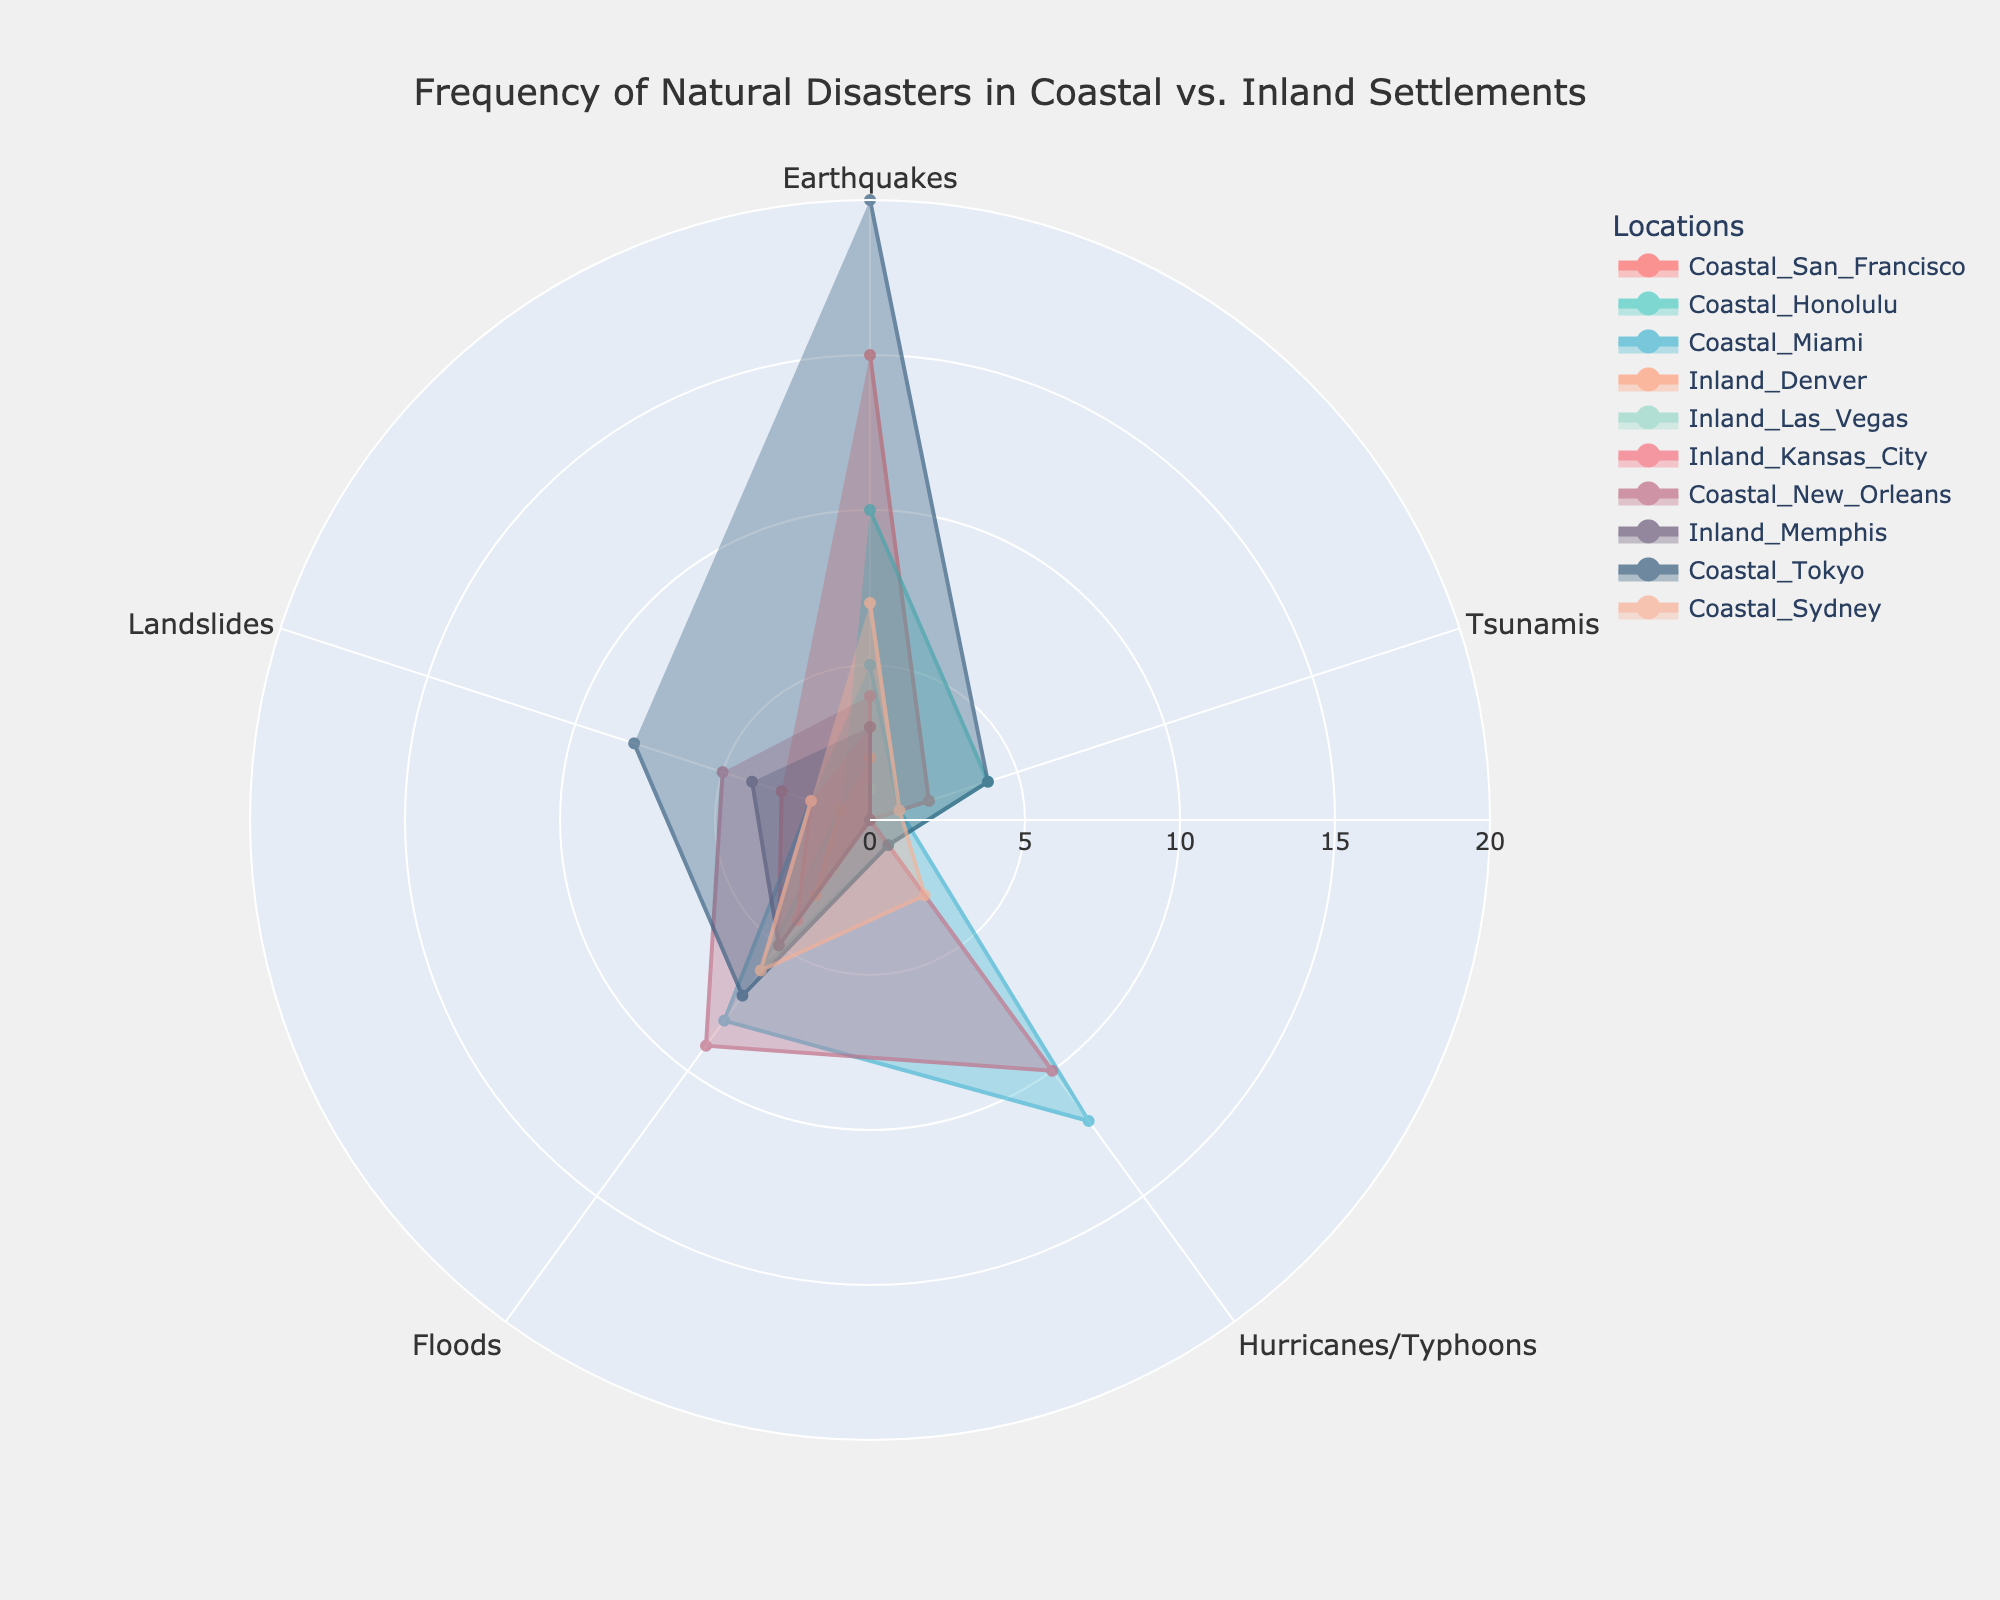What is the title of the radar chart? The title can be found at the top of the radar chart and provides a succinct summary of the data being represented.
Answer: Frequency of Natural Disasters in Coastal vs. Inland Settlements Which coastal location has the highest frequency of earthquakes? To determine this, look at the "Earthquakes" parameter on the radar chart and identify the coastal location with the highest point along this axis.
Answer: Tokyo How many more hurricanes/typhoons does Miami experience compared to New Orleans? Locate the values for the "Hurricanes/Typhoons" axis for both Miami and New Orleans, then subtract New Orleans' value from Miami's value.
Answer: 2 What location experiences the highest frequency of landslides? Check the "Landslides" parameter on the radar chart and find the location that has the highest value along this axis.
Answer: Tokyo Among the inland locations, which city has the highest total frequency of natural disasters? Sum the values of all natural disaster types for each inland location and compare the totals. Denver: 2+0+0+3+1=6; Las Vegas: 1+0+0+2+0=3; Kansas City: 3+0+0+4+2=9; Memphis: 3+0+0+5+4=12. Memphis has the highest total frequency.
Answer: Memphis Compare the frequency of floods between coastal and inland cities. Which type of location generally experiences more floods? Calculate the average frequency of floods for coastal locations and for inland locations. Coastal: (5+6+8+9+7+6)/6 = 6.833; Inland: (3+2+4+5)/4 = 3.5. Coastal locations have a higher average frequency of floods.
Answer: Coastal For tsunamis, which coastal city has the lowest frequency, and what is that frequency? Look at the frequencies along the "Tsunamis" axis and find the coastal city with the lowest value.
Answer: New Orleans, with 0 Is the frequency of hurricanes/typhoons in Tokyo greater than or less than in Sydney? Compare the values along the "Hurricanes/Typhoons" axis for Tokyo and Sydney.
Answer: Less What is the combined frequency of earthquakes in San Francisco and earthquakes in Denver? Add the "Earthquakes" values for San Francisco and Denver.
Answer: 17 How does the frequency of earthquakes in Tokyo compare to the frequency of floods in New Orleans? Identify and compare the values for Tokyo along the "Earthquakes" axis and for New Orleans along the "Floods" axis.
Answer: Tokyo has more (Tokyo: 20, New Orleans: 9) 